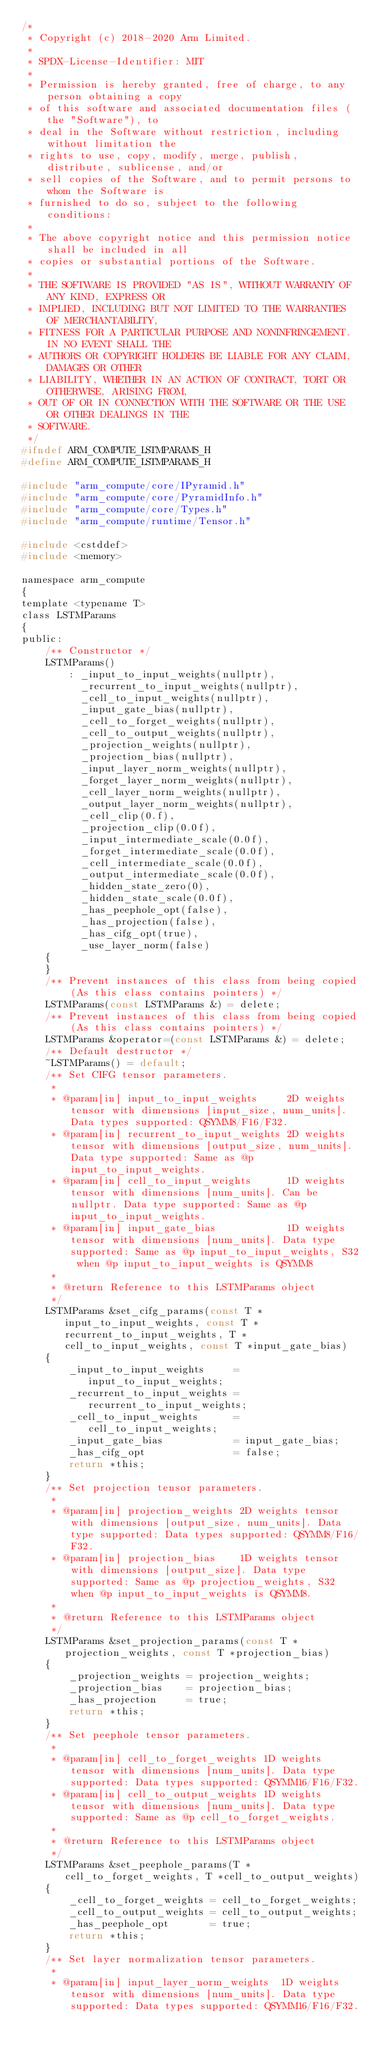<code> <loc_0><loc_0><loc_500><loc_500><_C_>/*
 * Copyright (c) 2018-2020 Arm Limited.
 *
 * SPDX-License-Identifier: MIT
 *
 * Permission is hereby granted, free of charge, to any person obtaining a copy
 * of this software and associated documentation files (the "Software"), to
 * deal in the Software without restriction, including without limitation the
 * rights to use, copy, modify, merge, publish, distribute, sublicense, and/or
 * sell copies of the Software, and to permit persons to whom the Software is
 * furnished to do so, subject to the following conditions:
 *
 * The above copyright notice and this permission notice shall be included in all
 * copies or substantial portions of the Software.
 *
 * THE SOFTWARE IS PROVIDED "AS IS", WITHOUT WARRANTY OF ANY KIND, EXPRESS OR
 * IMPLIED, INCLUDING BUT NOT LIMITED TO THE WARRANTIES OF MERCHANTABILITY,
 * FITNESS FOR A PARTICULAR PURPOSE AND NONINFRINGEMENT. IN NO EVENT SHALL THE
 * AUTHORS OR COPYRIGHT HOLDERS BE LIABLE FOR ANY CLAIM, DAMAGES OR OTHER
 * LIABILITY, WHETHER IN AN ACTION OF CONTRACT, TORT OR OTHERWISE, ARISING FROM,
 * OUT OF OR IN CONNECTION WITH THE SOFTWARE OR THE USE OR OTHER DEALINGS IN THE
 * SOFTWARE.
 */
#ifndef ARM_COMPUTE_LSTMPARAMS_H
#define ARM_COMPUTE_LSTMPARAMS_H

#include "arm_compute/core/IPyramid.h"
#include "arm_compute/core/PyramidInfo.h"
#include "arm_compute/core/Types.h"
#include "arm_compute/runtime/Tensor.h"

#include <cstddef>
#include <memory>

namespace arm_compute
{
template <typename T>
class LSTMParams
{
public:
    /** Constructor */
    LSTMParams()
        : _input_to_input_weights(nullptr),
          _recurrent_to_input_weights(nullptr),
          _cell_to_input_weights(nullptr),
          _input_gate_bias(nullptr),
          _cell_to_forget_weights(nullptr),
          _cell_to_output_weights(nullptr),
          _projection_weights(nullptr),
          _projection_bias(nullptr),
          _input_layer_norm_weights(nullptr),
          _forget_layer_norm_weights(nullptr),
          _cell_layer_norm_weights(nullptr),
          _output_layer_norm_weights(nullptr),
          _cell_clip(0.f),
          _projection_clip(0.0f),
          _input_intermediate_scale(0.0f),
          _forget_intermediate_scale(0.0f),
          _cell_intermediate_scale(0.0f),
          _output_intermediate_scale(0.0f),
          _hidden_state_zero(0),
          _hidden_state_scale(0.0f),
          _has_peephole_opt(false),
          _has_projection(false),
          _has_cifg_opt(true),
          _use_layer_norm(false)
    {
    }
    /** Prevent instances of this class from being copied (As this class contains pointers) */
    LSTMParams(const LSTMParams &) = delete;
    /** Prevent instances of this class from being copied (As this class contains pointers) */
    LSTMParams &operator=(const LSTMParams &) = delete;
    /** Default destructor */
    ~LSTMParams() = default;
    /** Set CIFG tensor parameters.
     *
     * @param[in] input_to_input_weights     2D weights tensor with dimensions [input_size, num_units]. Data types supported: QSYMM8/F16/F32.
     * @param[in] recurrent_to_input_weights 2D weights tensor with dimensions [output_size, num_units]. Data type supported: Same as @p input_to_input_weights.
     * @param[in] cell_to_input_weights      1D weights tensor with dimensions [num_units]. Can be nullptr. Data type supported: Same as @p input_to_input_weights.
     * @param[in] input_gate_bias            1D weights tensor with dimensions [num_units]. Data type supported: Same as @p input_to_input_weights, S32 when @p input_to_input_weights is QSYMM8
     *
     * @return Reference to this LSTMParams object
     */
    LSTMParams &set_cifg_params(const T *input_to_input_weights, const T *recurrent_to_input_weights, T *cell_to_input_weights, const T *input_gate_bias)
    {
        _input_to_input_weights     = input_to_input_weights;
        _recurrent_to_input_weights = recurrent_to_input_weights;
        _cell_to_input_weights      = cell_to_input_weights;
        _input_gate_bias            = input_gate_bias;
        _has_cifg_opt               = false;
        return *this;
    }
    /** Set projection tensor parameters.
     *
     * @param[in] projection_weights 2D weights tensor with dimensions [output_size, num_units]. Data type supported: Data types supported: QSYMM8/F16/F32.
     * @param[in] projection_bias    1D weights tensor with dimensions [output_size]. Data type supported: Same as @p projection_weights, S32 when @p input_to_input_weights is QSYMM8.
     *
     * @return Reference to this LSTMParams object
     */
    LSTMParams &set_projection_params(const T *projection_weights, const T *projection_bias)
    {
        _projection_weights = projection_weights;
        _projection_bias    = projection_bias;
        _has_projection     = true;
        return *this;
    }
    /** Set peephole tensor parameters.
     *
     * @param[in] cell_to_forget_weights 1D weights tensor with dimensions [num_units]. Data type supported: Data types supported: QSYMM16/F16/F32.
     * @param[in] cell_to_output_weights 1D weights tensor with dimensions [num_units]. Data type supported: Same as @p cell_to_forget_weights.
     *
     * @return Reference to this LSTMParams object
     */
    LSTMParams &set_peephole_params(T *cell_to_forget_weights, T *cell_to_output_weights)
    {
        _cell_to_forget_weights = cell_to_forget_weights;
        _cell_to_output_weights = cell_to_output_weights;
        _has_peephole_opt       = true;
        return *this;
    }
    /** Set layer normalization tensor parameters.
     *
     * @param[in] input_layer_norm_weights  1D weights tensor with dimensions [num_units]. Data type supported: Data types supported: QSYMM16/F16/F32.</code> 